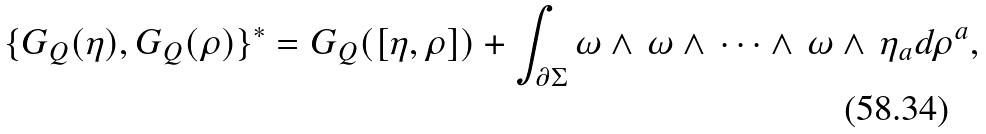<formula> <loc_0><loc_0><loc_500><loc_500>\{ G _ { Q } ( \eta ) , G _ { Q } ( \rho ) \} ^ { * } = G _ { Q } ( [ \eta , \rho ] ) + \int _ { \partial \Sigma } \omega \wedge \, \omega \wedge \, \dots \wedge \, \omega \wedge \, \eta _ { a } d \rho ^ { a } ,</formula> 